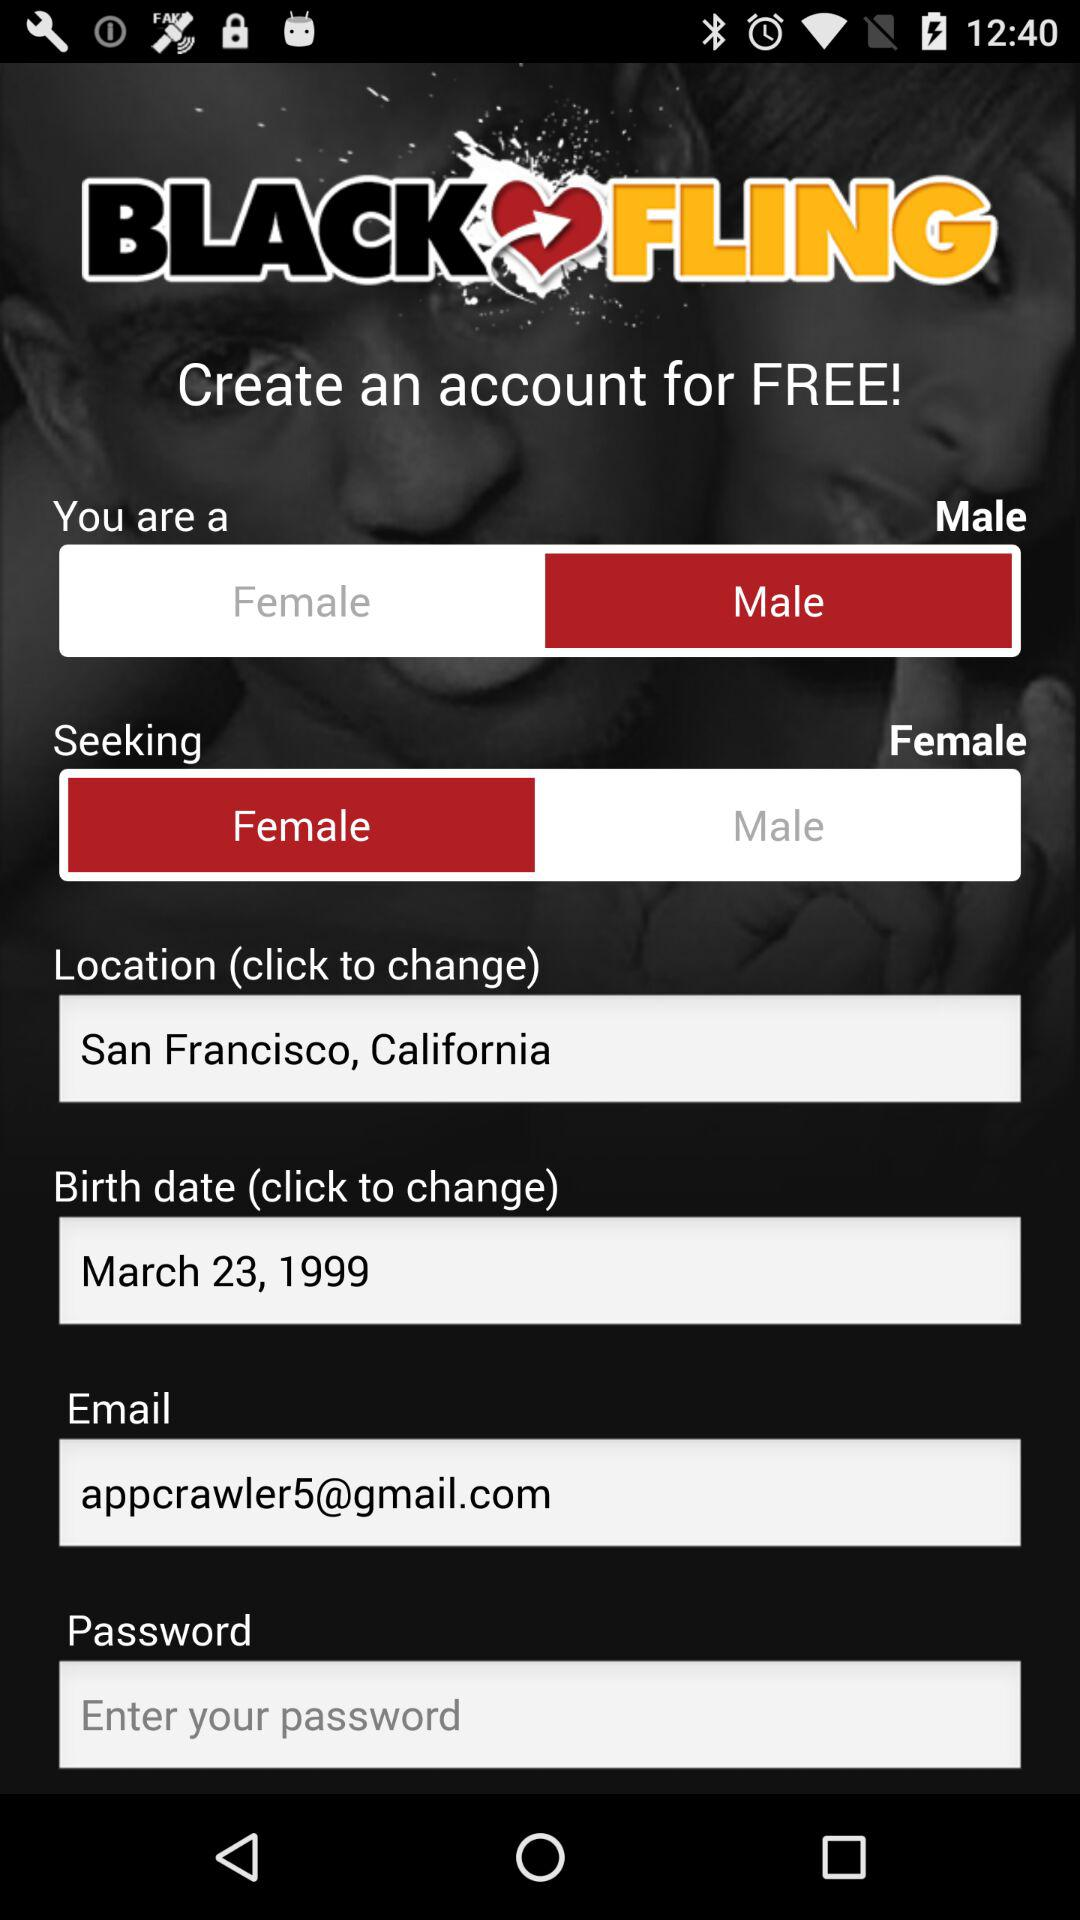What is the name of the application? The name of the application is "BLACK FLING". 